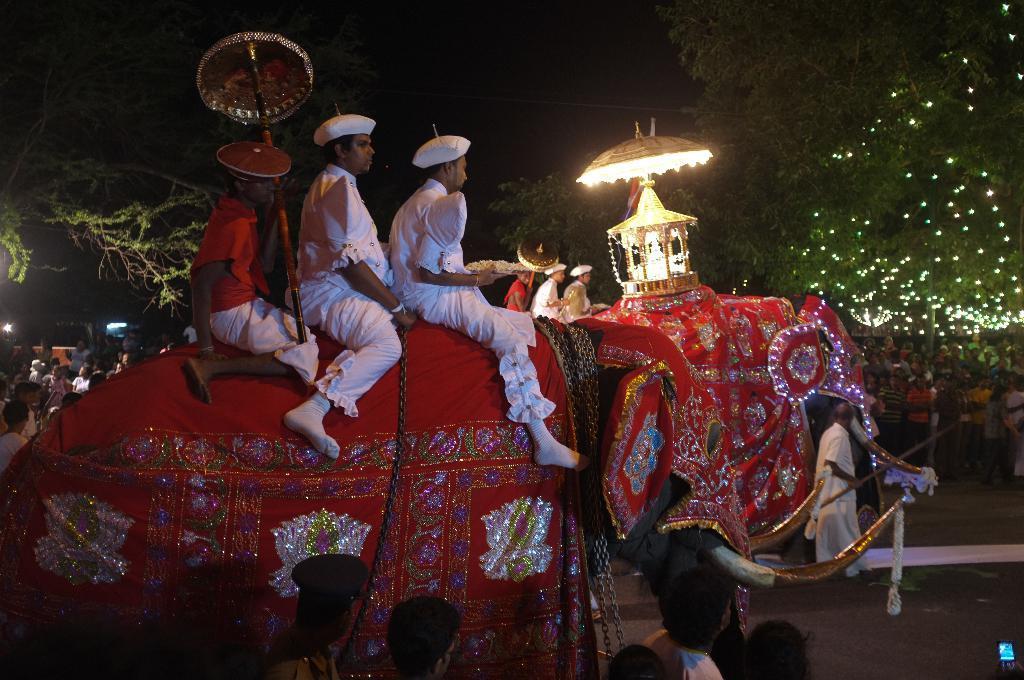Can you describe this image briefly? In this picture there are three people sitting on an elephant and two of them are dressed in white color and a small light is placed on top of the elephant. In the background there are several spectators viewing them and trees are decorated with lights. 